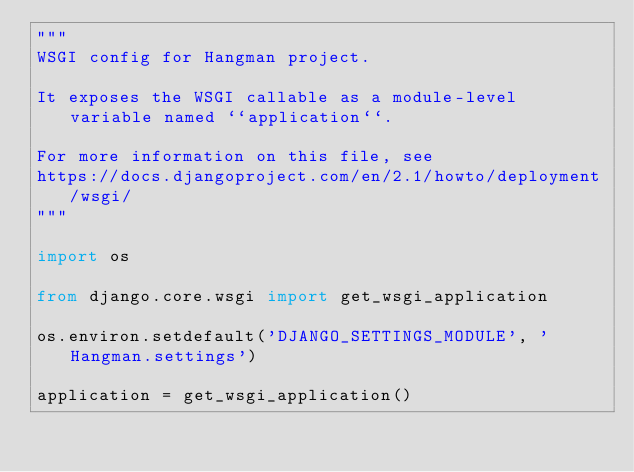Convert code to text. <code><loc_0><loc_0><loc_500><loc_500><_Python_>"""
WSGI config for Hangman project.

It exposes the WSGI callable as a module-level variable named ``application``.

For more information on this file, see
https://docs.djangoproject.com/en/2.1/howto/deployment/wsgi/
"""

import os

from django.core.wsgi import get_wsgi_application

os.environ.setdefault('DJANGO_SETTINGS_MODULE', 'Hangman.settings')

application = get_wsgi_application()
</code> 